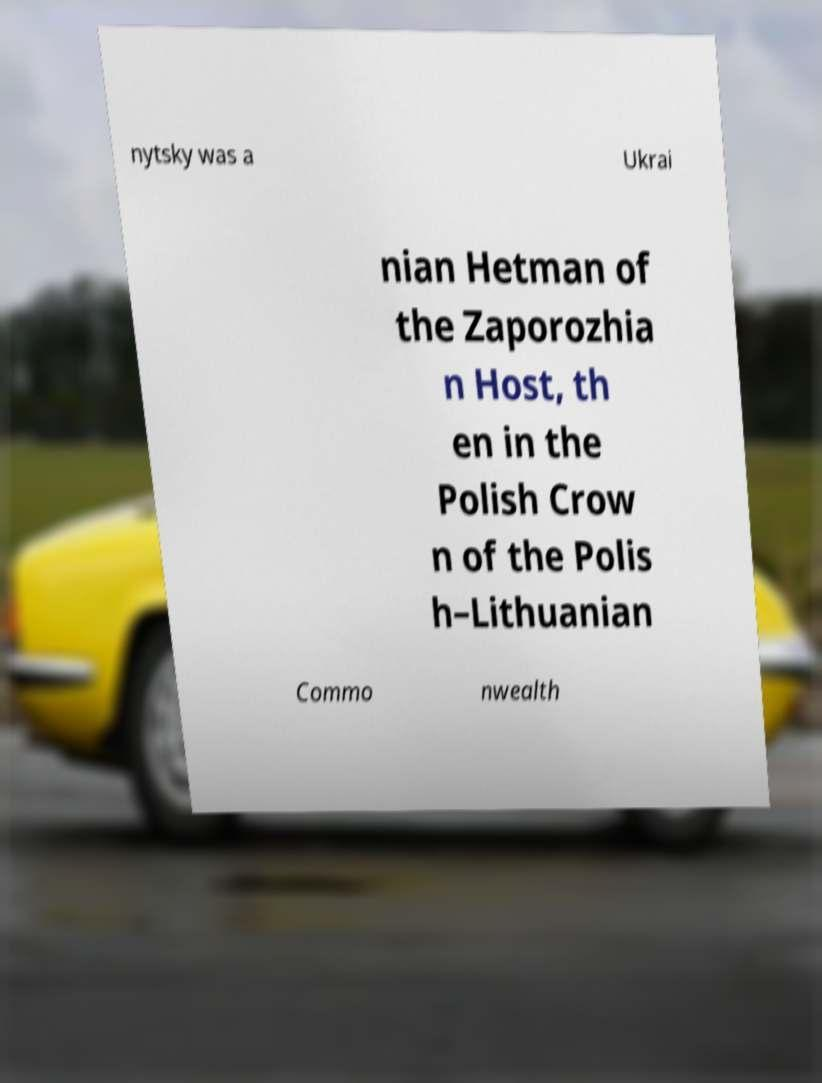Can you accurately transcribe the text from the provided image for me? nytsky was a Ukrai nian Hetman of the Zaporozhia n Host, th en in the Polish Crow n of the Polis h–Lithuanian Commo nwealth 